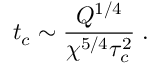Convert formula to latex. <formula><loc_0><loc_0><loc_500><loc_500>t _ { c } \sim \frac { Q ^ { 1 / 4 } } { \chi ^ { 5 / 4 } \tau _ { c } ^ { 2 } } \, .</formula> 